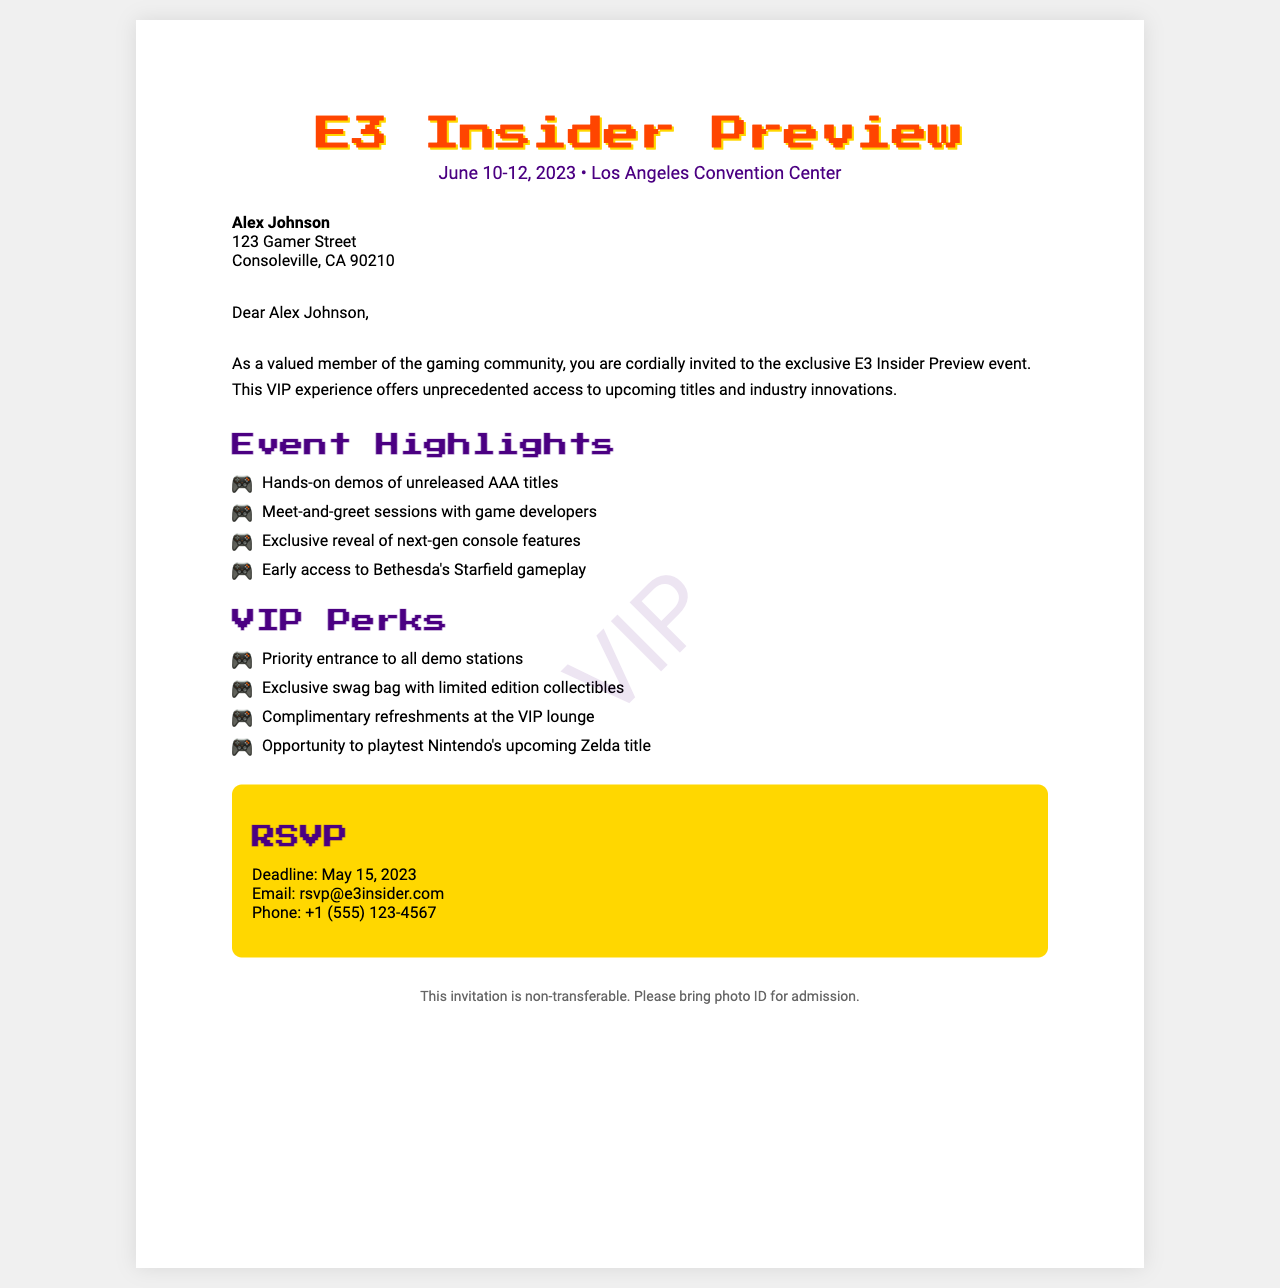What is the event name? The event name is prominently displayed at the top of the document as part of the fax header.
Answer: E3 Insider Preview What are the event dates? The event dates are located right below the event name in the same header section.
Answer: June 10-12, 2023 Who is the invitation addressed to? The recipient’s name appears at the top of the recipient section in bold.
Answer: Alex Johnson What is one of the event highlights? The highlights section lists various features of the event, which can be found under the "Event Highlights" heading.
Answer: Hands-on demos of unreleased AAA titles What is the RSVP deadline? The RSVP deadline is mentioned in the RSVP section of the document with specific contact details.
Answer: May 15, 2023 What is required for admission? The footer of the document states the requirement for admission to the event.
Answer: Photo ID What is included in the VIP Perks? The VIP Perks section lists benefits that come with the VIP experience during the event.
Answer: Exclusive swag bag with limited edition collectibles What is the contact email for RSVP? The RSVP section provides specific contact details, including an email address for responses.
Answer: rsvp@e3insider.com How many days is the event? The event runs from June 10 to June 12, 2023, which can be calculated from the dates provided.
Answer: 3 days 